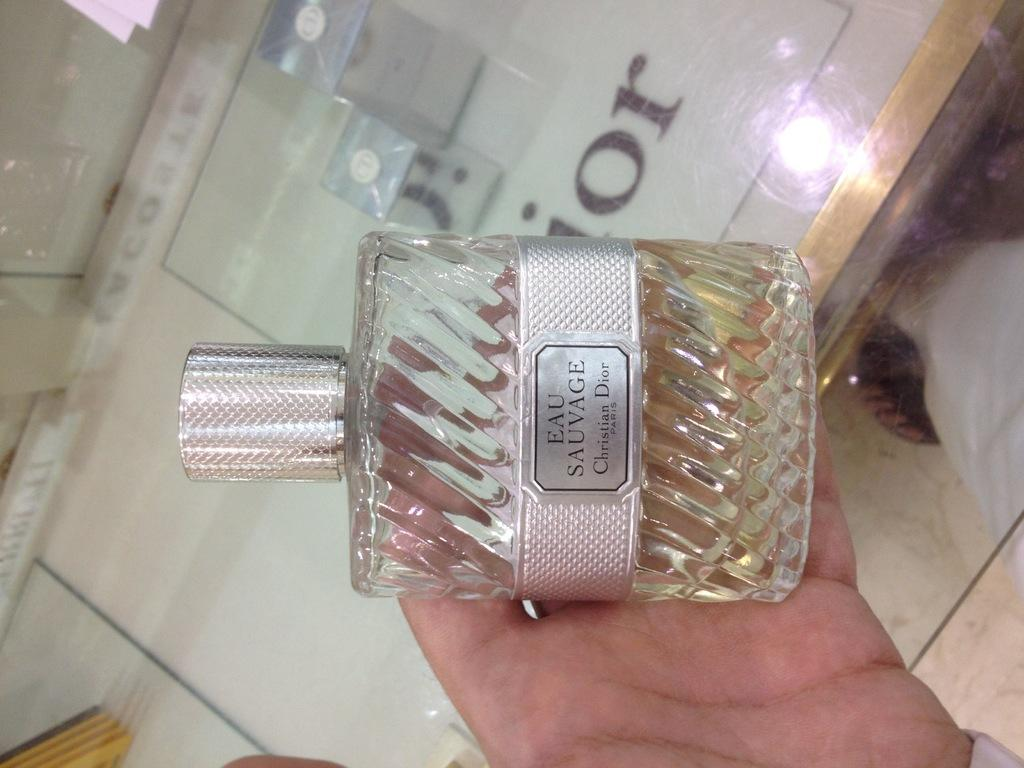<image>
Relay a brief, clear account of the picture shown. A bottle of Christian Dior perfume is being held. 